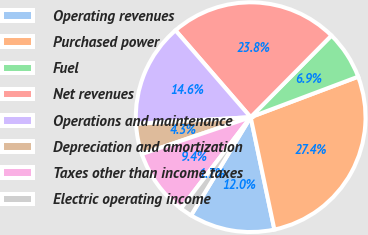<chart> <loc_0><loc_0><loc_500><loc_500><pie_chart><fcel>Operating revenues<fcel>Purchased power<fcel>Fuel<fcel>Net revenues<fcel>Operations and maintenance<fcel>Depreciation and amortization<fcel>Taxes other than income taxes<fcel>Electric operating income<nl><fcel>11.99%<fcel>27.42%<fcel>6.85%<fcel>23.77%<fcel>14.56%<fcel>4.28%<fcel>9.42%<fcel>1.7%<nl></chart> 